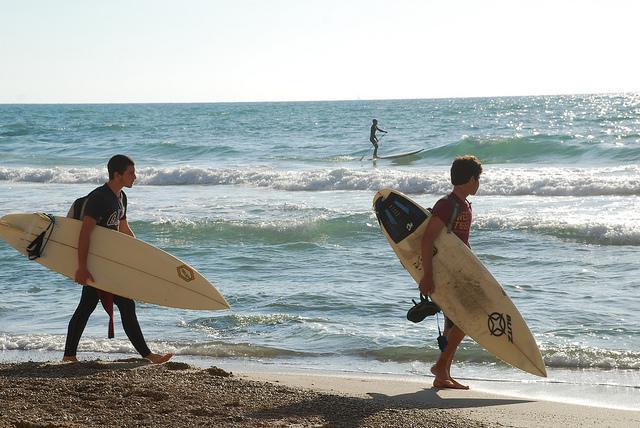How many people are there?
Give a very brief answer. 2. How many surfboards can be seen?
Give a very brief answer. 2. How many real cats are in this photo?
Give a very brief answer. 0. 